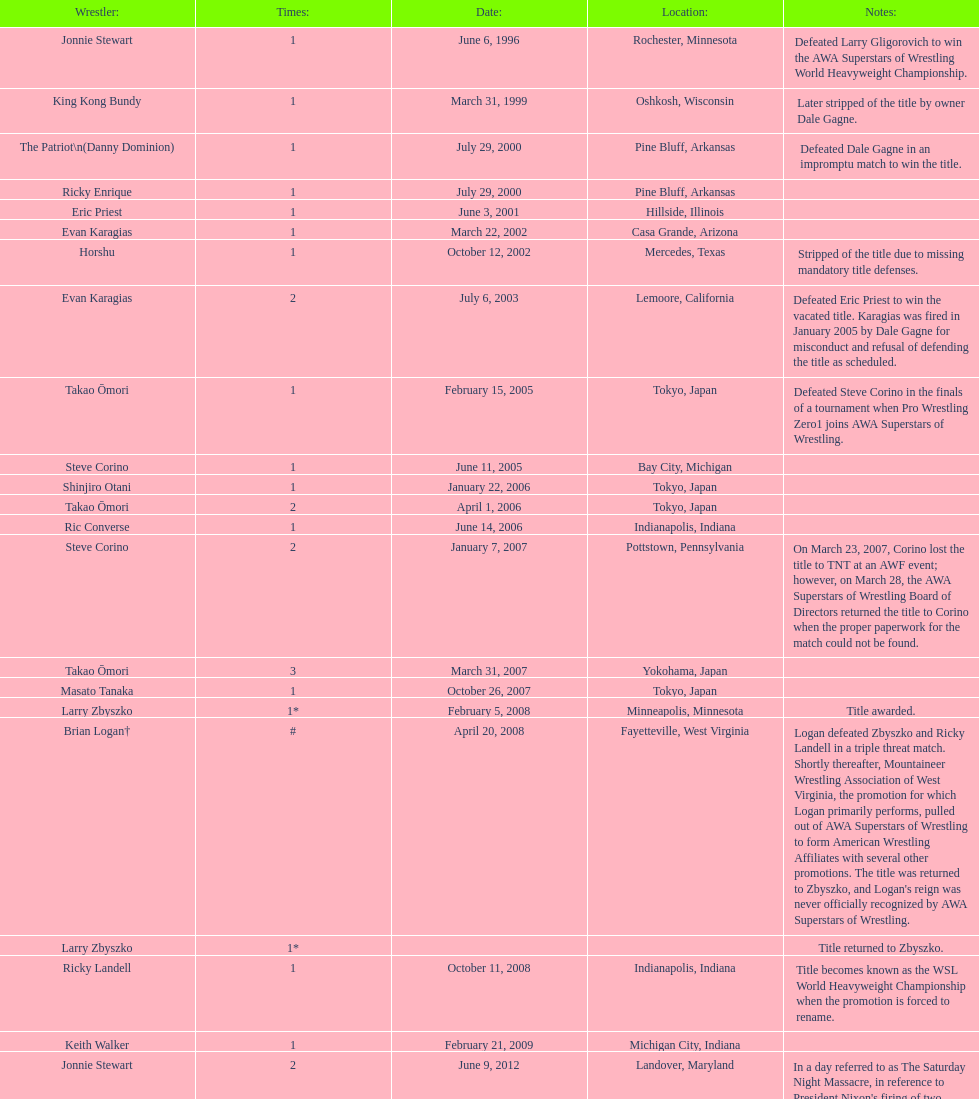Which wrestler was the final one to secure the title? The Honky Tonk Man. 